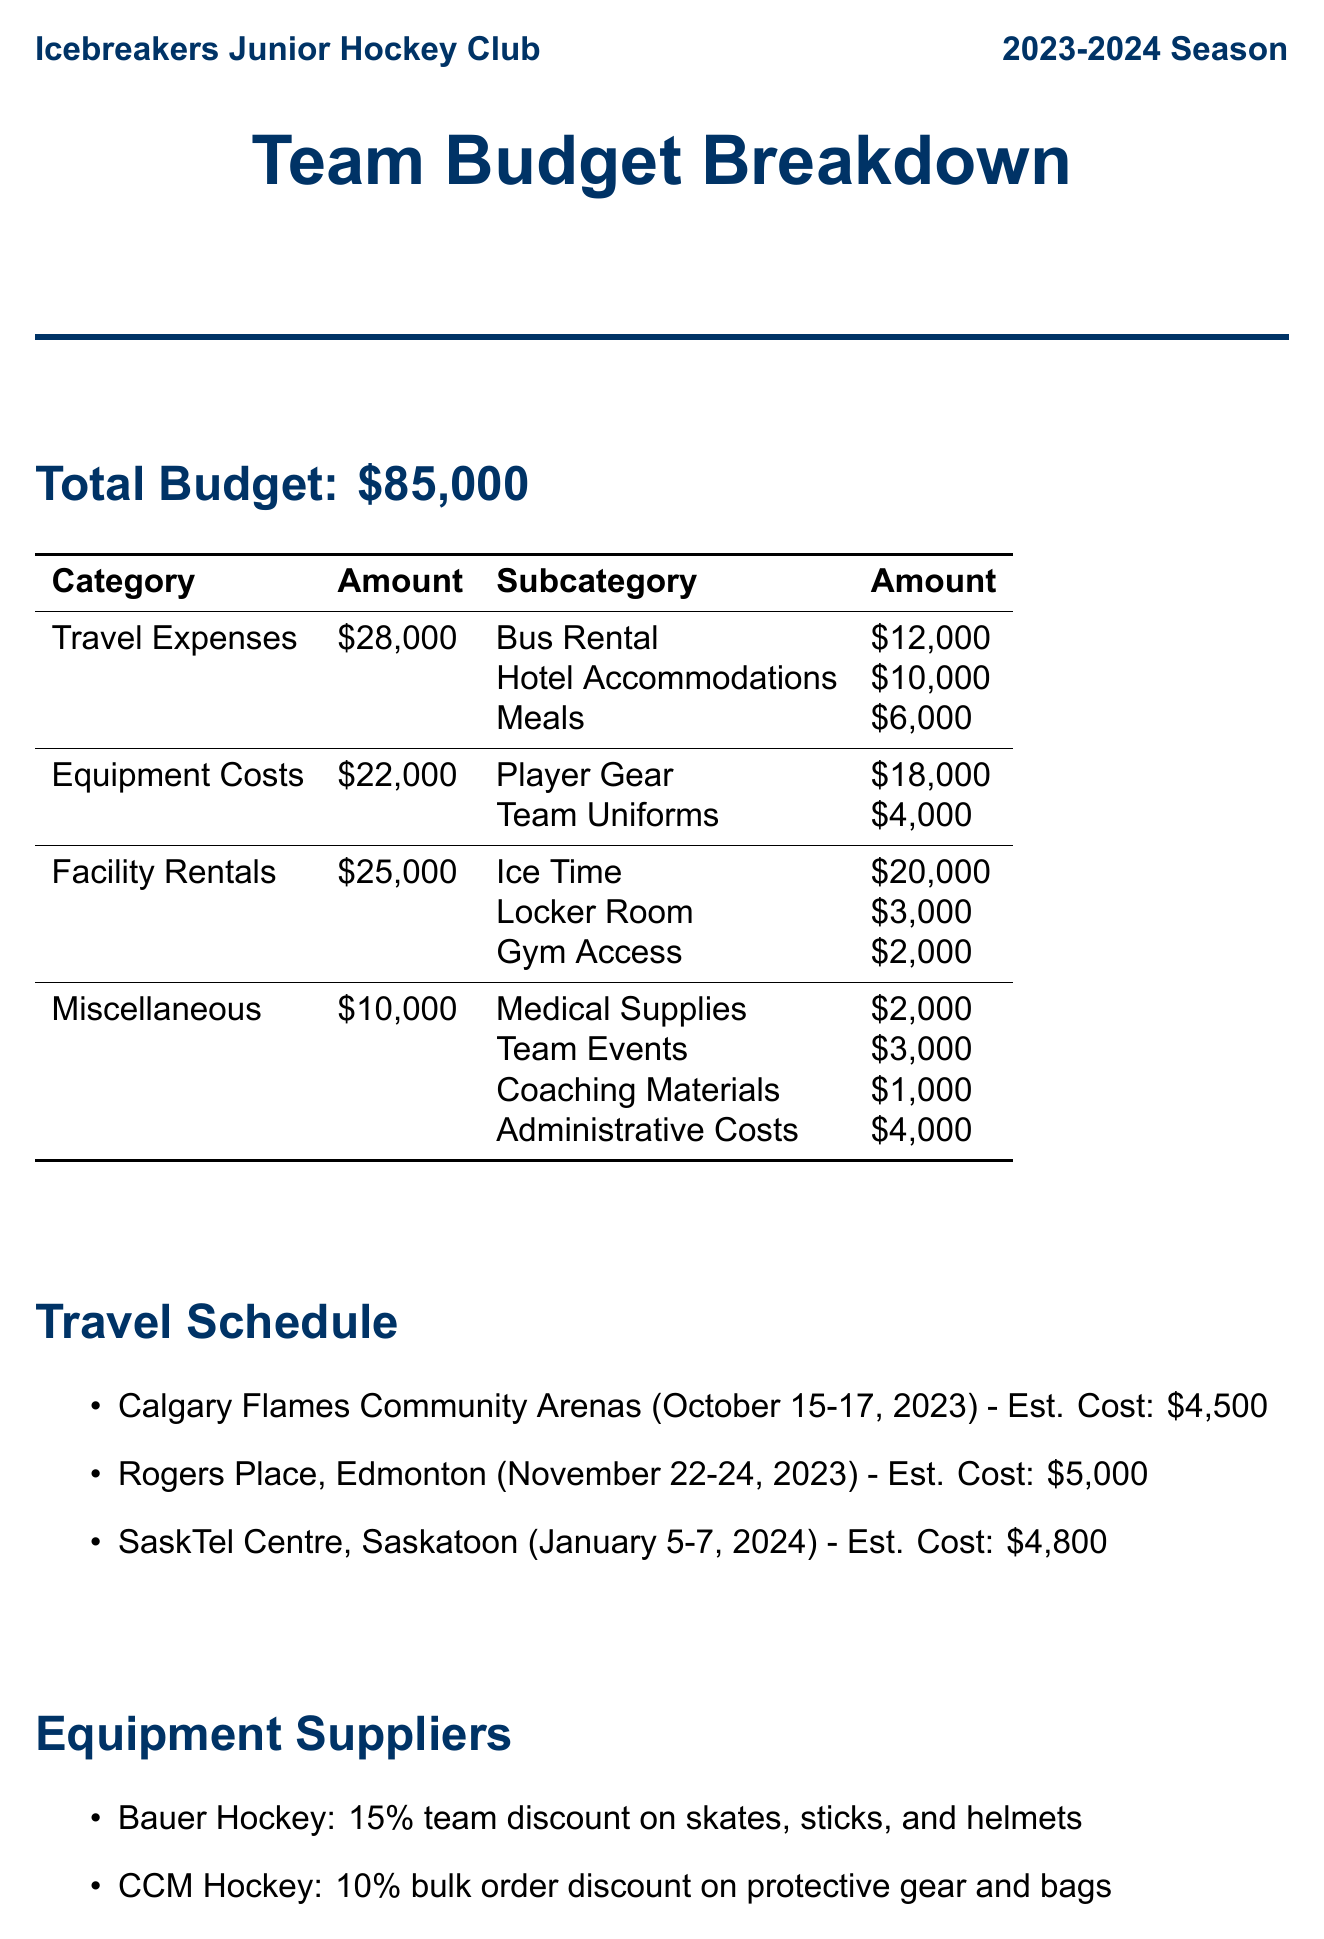What is the total budget? The total budget for the Icebreakers Junior Hockey Club for the 2023-2024 season is specified in the document.
Answer: $85,000 How much is allocated for travel expenses? The document details the breakdown of the budget, including a specific section for travel expenses.
Answer: $28,000 What is the estimated cost for the trip to Rogers Place, Edmonton? The travel schedule lists the estimated cost for each trip along with their respective destinations.
Answer: $5,000 How much is spent on medical supplies? The miscellaneous section of the budget includes costs for medical supplies among other categories.
Answer: $2,000 Which company contributed $5,000? The sponsorship section lists companies along with their contributions, specifying which companies contributed which amounts.
Answer: Tim Hortons What is the expected revenue from the Annual Skate-a-thon? The fundraising initiatives section outlines expected revenues from various events, including the Annual Skate-a-thon.
Answer: $5,000 How many practice sessions are held each week? The facility details section outlines the practice schedule, providing insight into how often practices occur.
Answer: 2 What percentage discount does Bauer Hockey offer? The equipment suppliers section lists the discounts offered by different suppliers, including Bauer Hockey's discount.
Answer: 15% What is the home arena for the Icebreakers? The facility details state the home arena, which is an important aspect of the team's identity and logistics.
Answer: Canlan Ice Sports York 